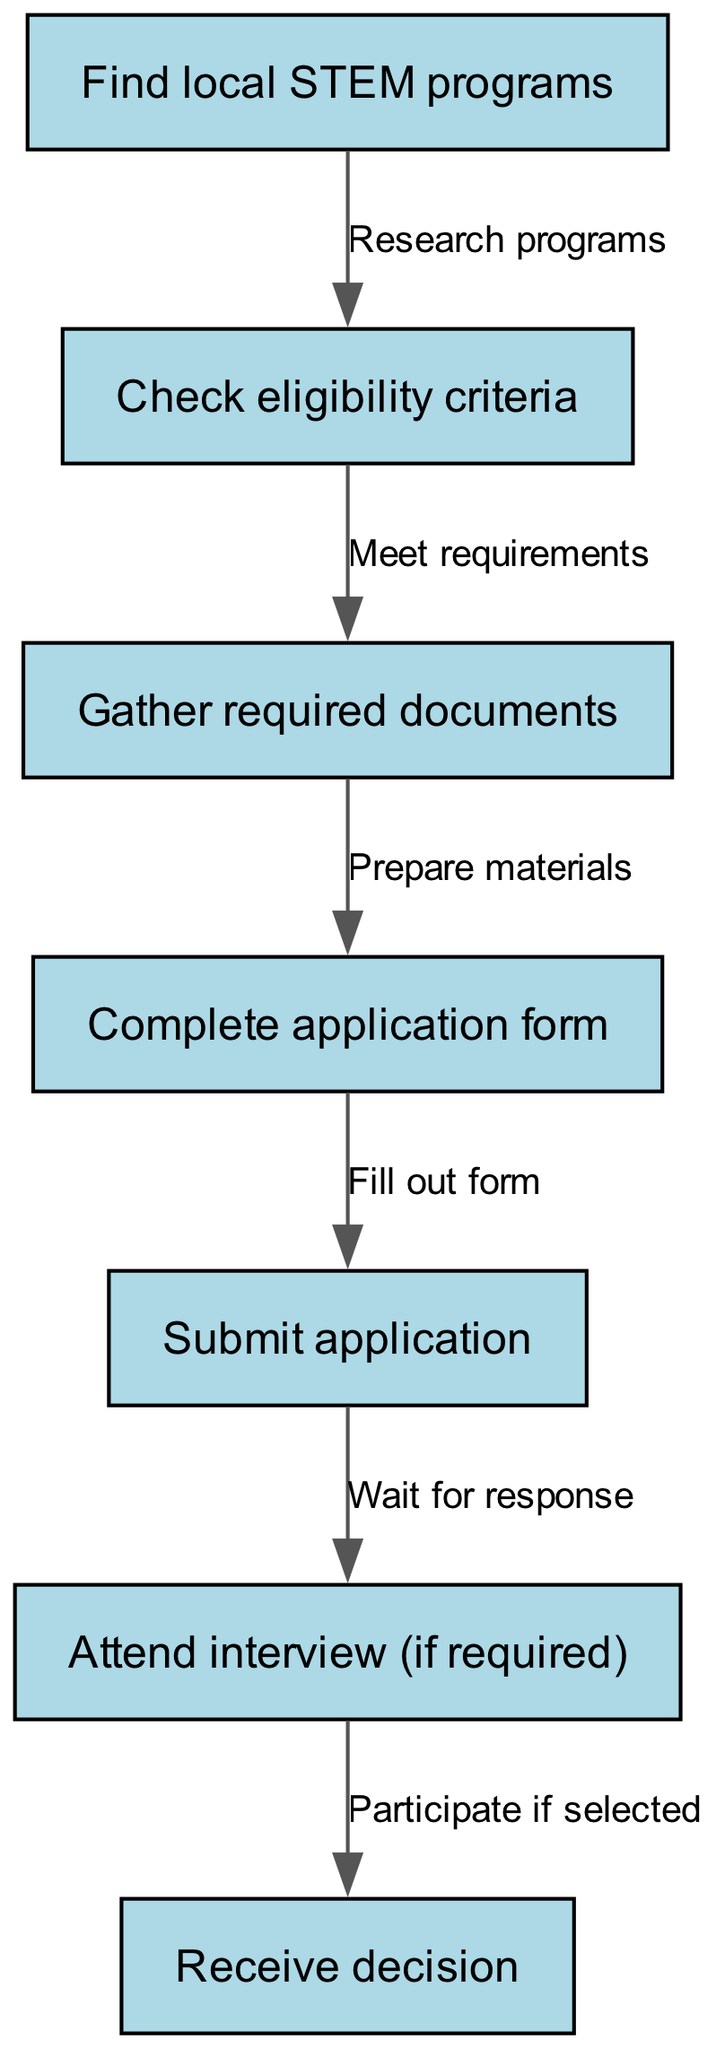What is the first step in the diagram? The first step listed in the diagram is "Find local STEM programs", which is the initial action that initiates the application process for after-school STEM programs.
Answer: Find local STEM programs How many nodes are in the diagram? By counting the nodes represented in the diagram, we can see that there are a total of 7 distinct steps listed from finding programs to receiving a decision.
Answer: 7 What is the outcome after submitting the application? Once the application is submitted, the next action is to "Attend interview (if required)", which indicates that participation in an interview may follow submission depending on the program's process.
Answer: Attend interview (if required) What do you need to do after gathering required documents? After gathering required documents, the subsequent step is to "Complete application form", where the gathered materials will be used to fill out the application.
Answer: Complete application form Which step follows checking eligibility criteria? The step that follows checking eligibility criteria is "Gather required documents", meaning that once you've confirmed you're eligible, you move on to collect the necessary paperwork for the application.
Answer: Gather required documents How many edges connect the nodes in the diagram? The edges represent the connections between the nodes, and in this diagram, there are 6 edges indicating the flow from one step to another in the application process.
Answer: 6 What is required before attending an interview? Attending an interview is dependent on being notified after "Submit application", affirming that an interview will only occur if the applicant is selected.
Answer: Submit application What action is represented by the edge going from node 5 to node 6? The edge from node 5 to node 6 represents the action "Wait for response", indicating that after submitting the application, you must wait before possibly attending an interview.
Answer: Wait for response 